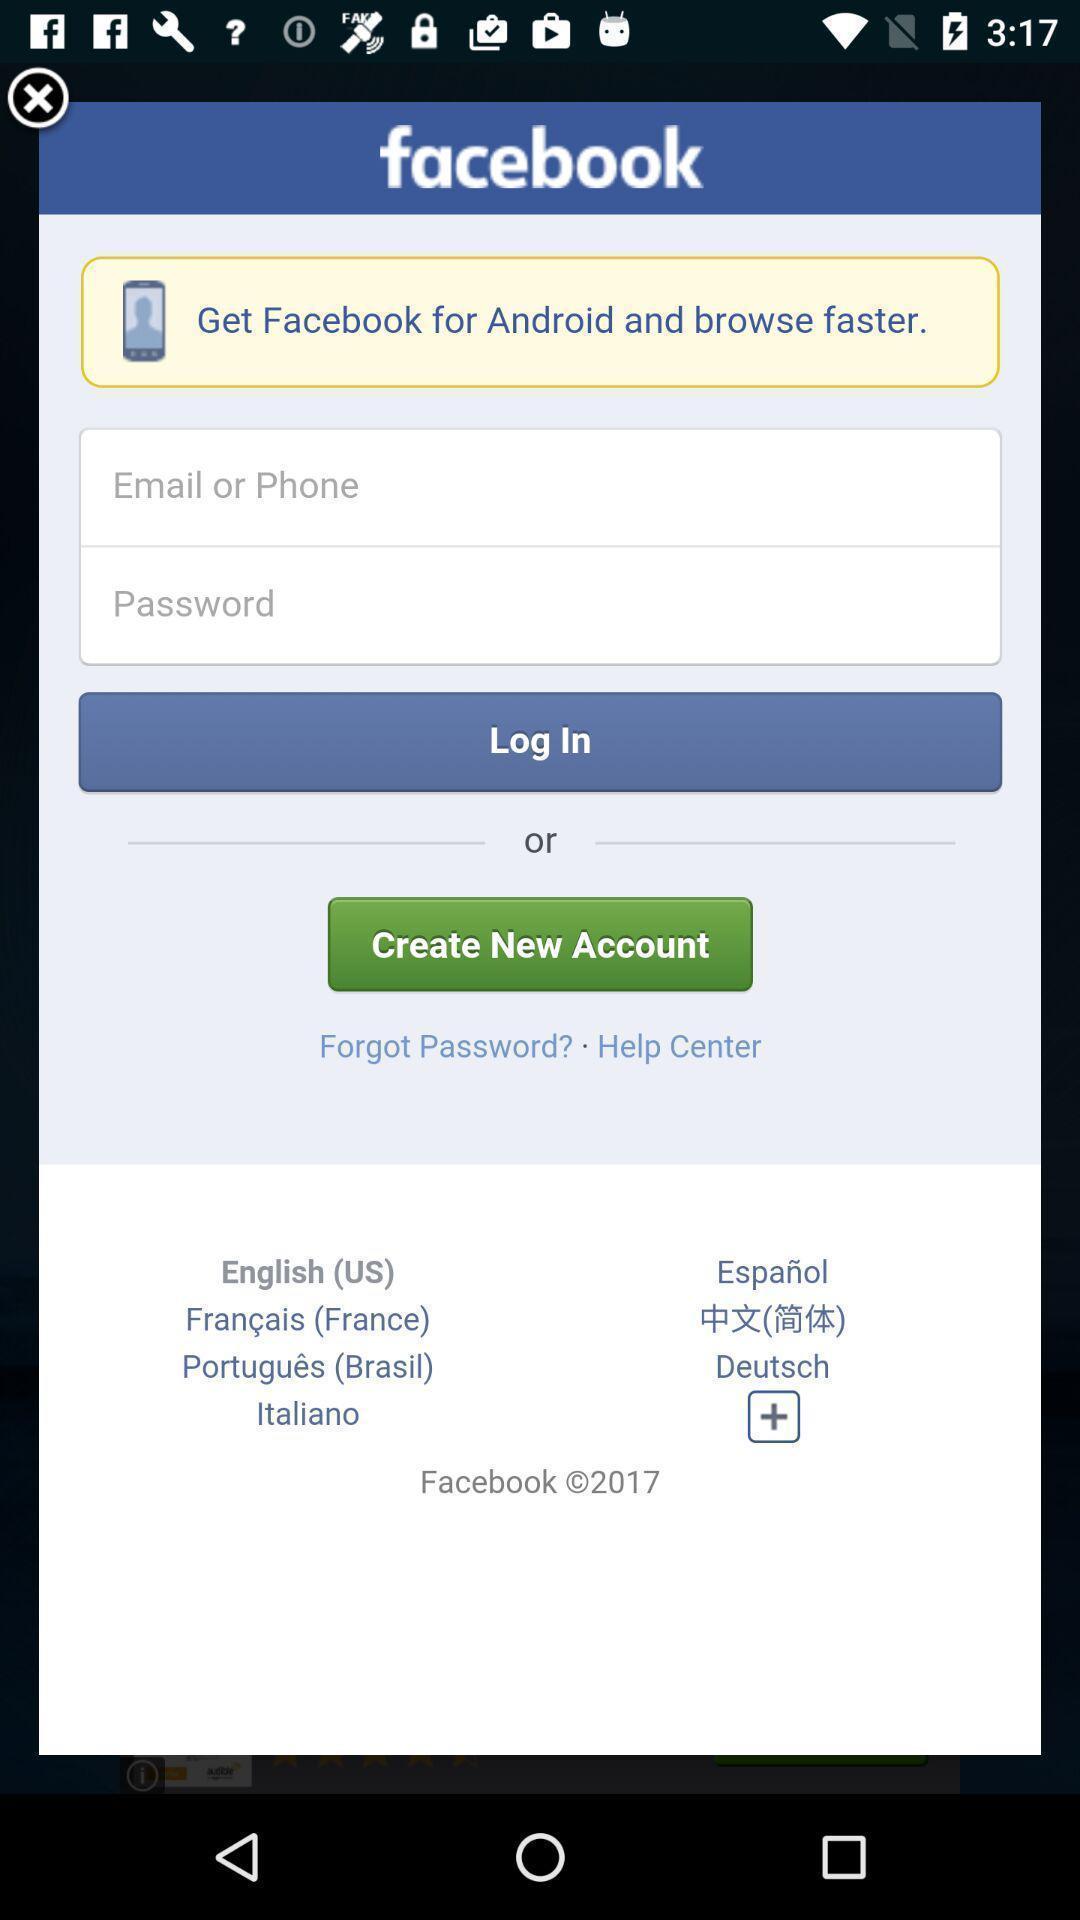Describe the visual elements of this screenshot. Pop-up displaying login page for a social app. 